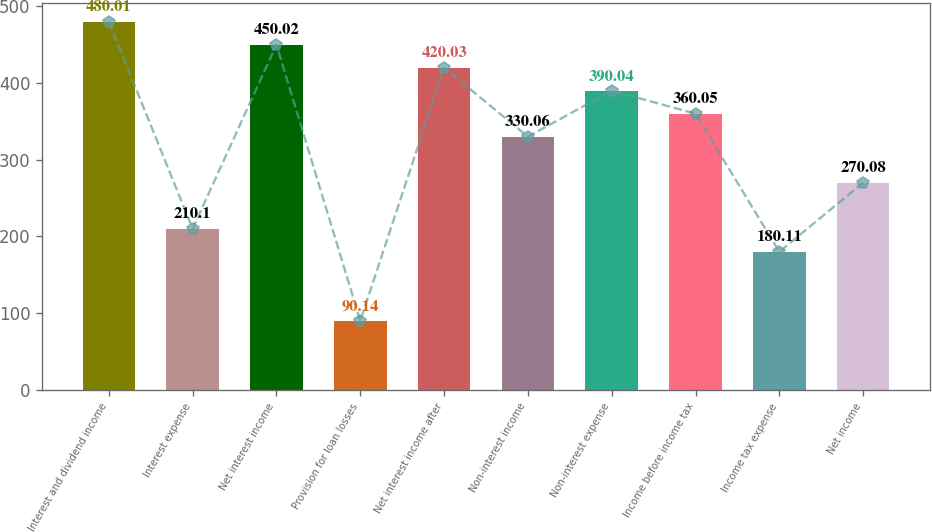<chart> <loc_0><loc_0><loc_500><loc_500><bar_chart><fcel>Interest and dividend income<fcel>Interest expense<fcel>Net interest income<fcel>Provision for loan losses<fcel>Net interest income after<fcel>Non-interest income<fcel>Non-interest expense<fcel>Income before income tax<fcel>Income tax expense<fcel>Net income<nl><fcel>480.01<fcel>210.1<fcel>450.02<fcel>90.14<fcel>420.03<fcel>330.06<fcel>390.04<fcel>360.05<fcel>180.11<fcel>270.08<nl></chart> 